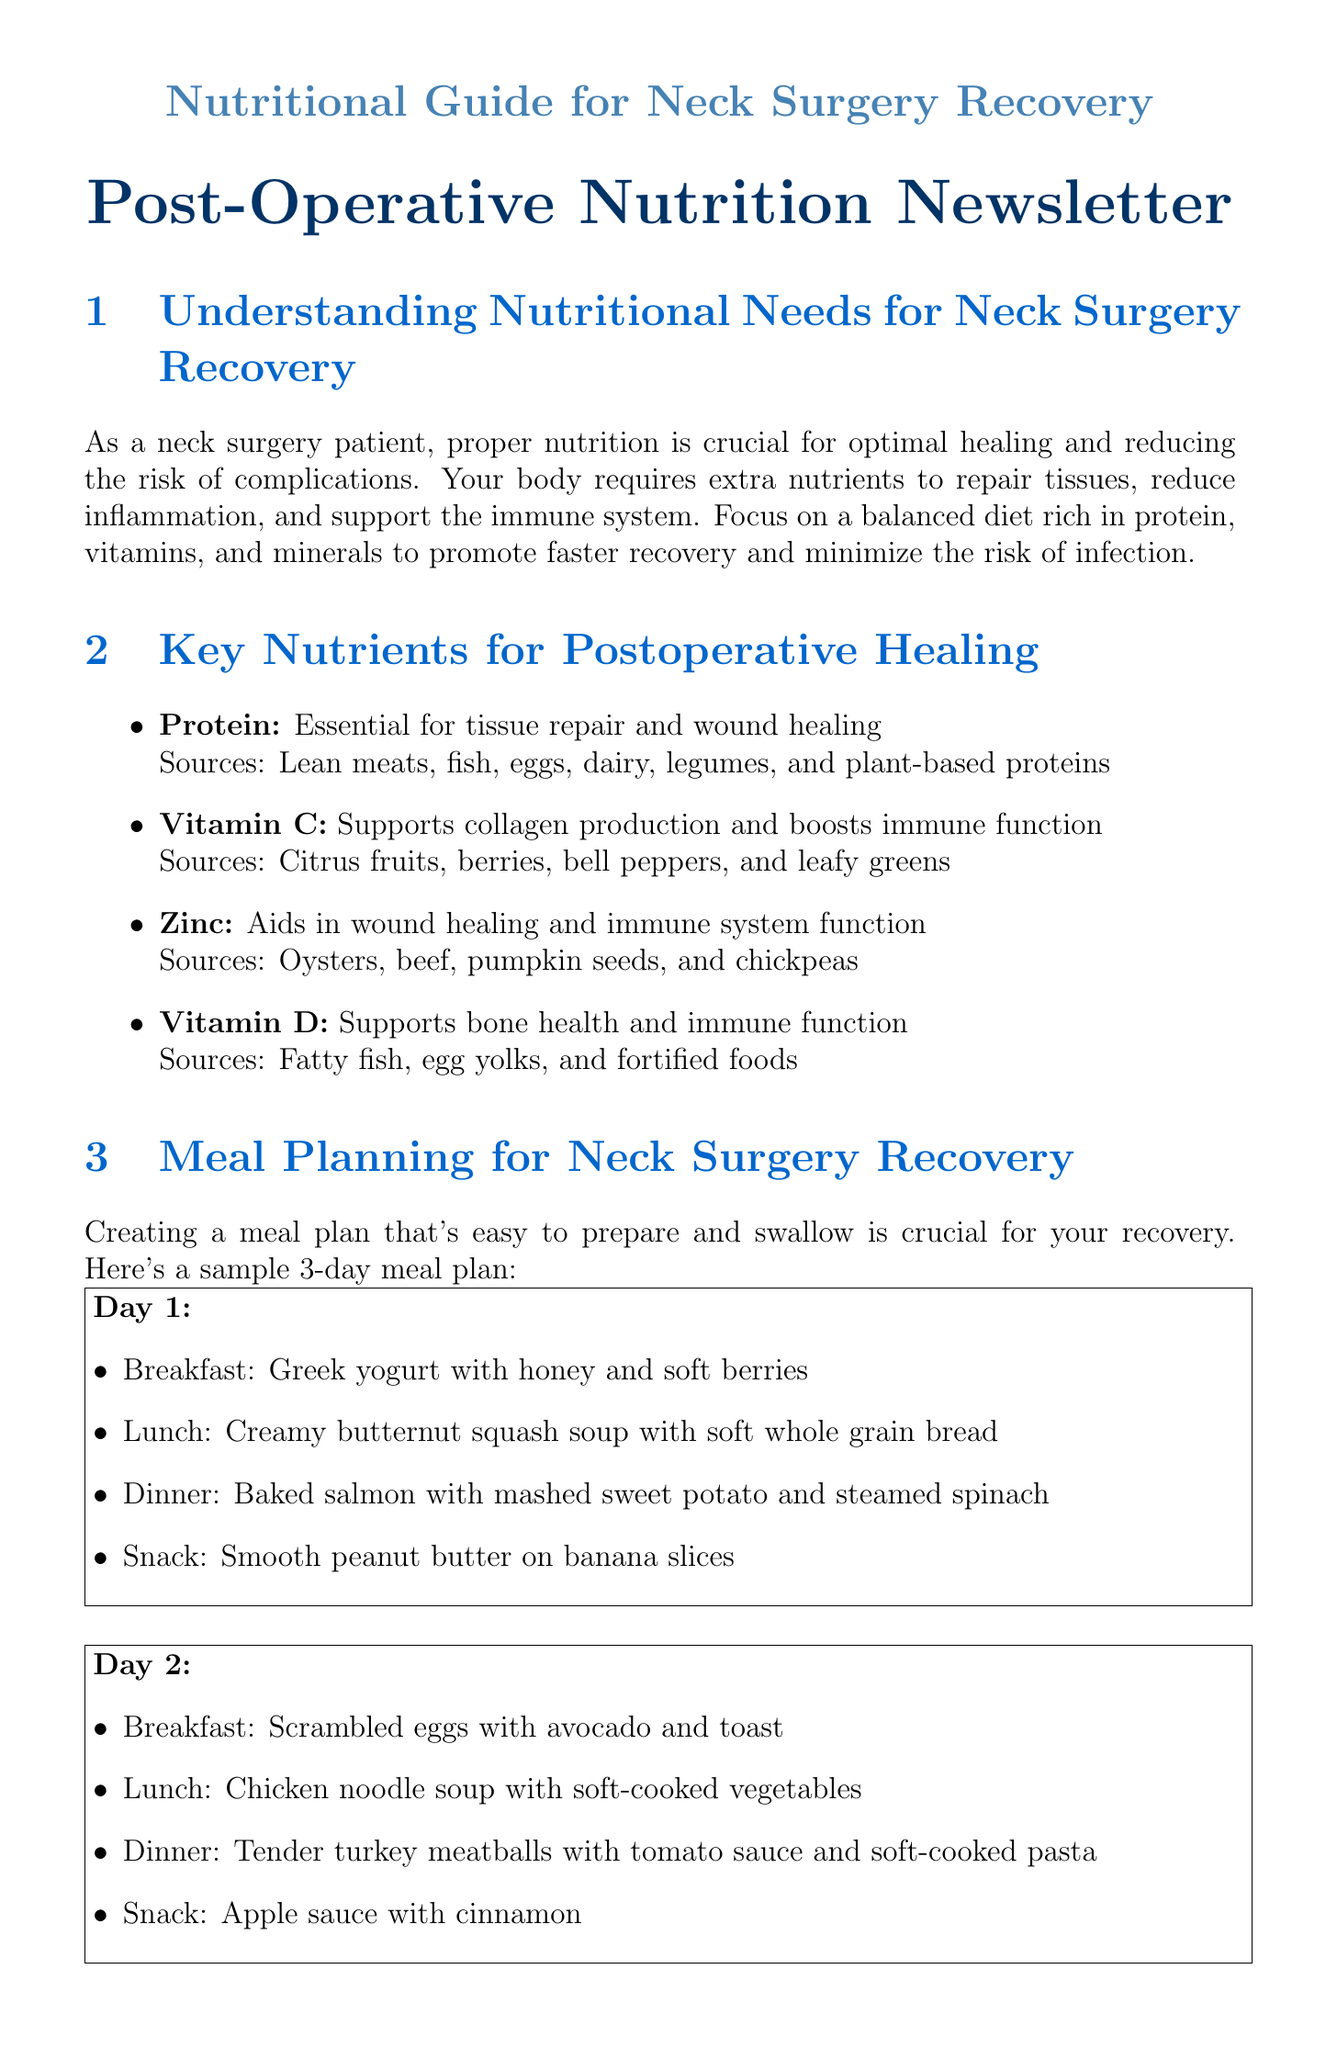What is the first section title in the newsletter? The title of the first section focuses on the importance of nutrition for neck surgery recovery.
Answer: Understanding Nutritional Needs for Neck Surgery Recovery Which nutrient supports collagen production? The document lists vitamins and their importance, highlighting vitamin C specifically for collagen.
Answer: Vitamin C What is a recommended beverage for hydration? The document suggests herbal teas for hydration and variety.
Answer: Herbal teas What is the main ingredient in the Green Recovery Smoothie? The recipe section specifies spinach as the primary ingredient in the smoothie.
Answer: Spinach How many glasses of water should patients aim to drink daily? The hydration tips recommend a specific amount of water intake to support healing.
Answer: 8 glasses Which food should be avoided during recovery due to irritation? The document lists certain foods that may cause discomfort, specifically spicy foods.
Answer: Spicy foods What ingredient in the meal plan is typically eaten for breakfast on Day 2? The meal plan indicates scrambled eggs as a breakfast option for the second day.
Answer: Scrambled eggs Which supplement is suggested for supporting healing? The newsletter lists multiple supplements that may be recommended by a doctor, one being a multivitamin.
Answer: Multivitamin 